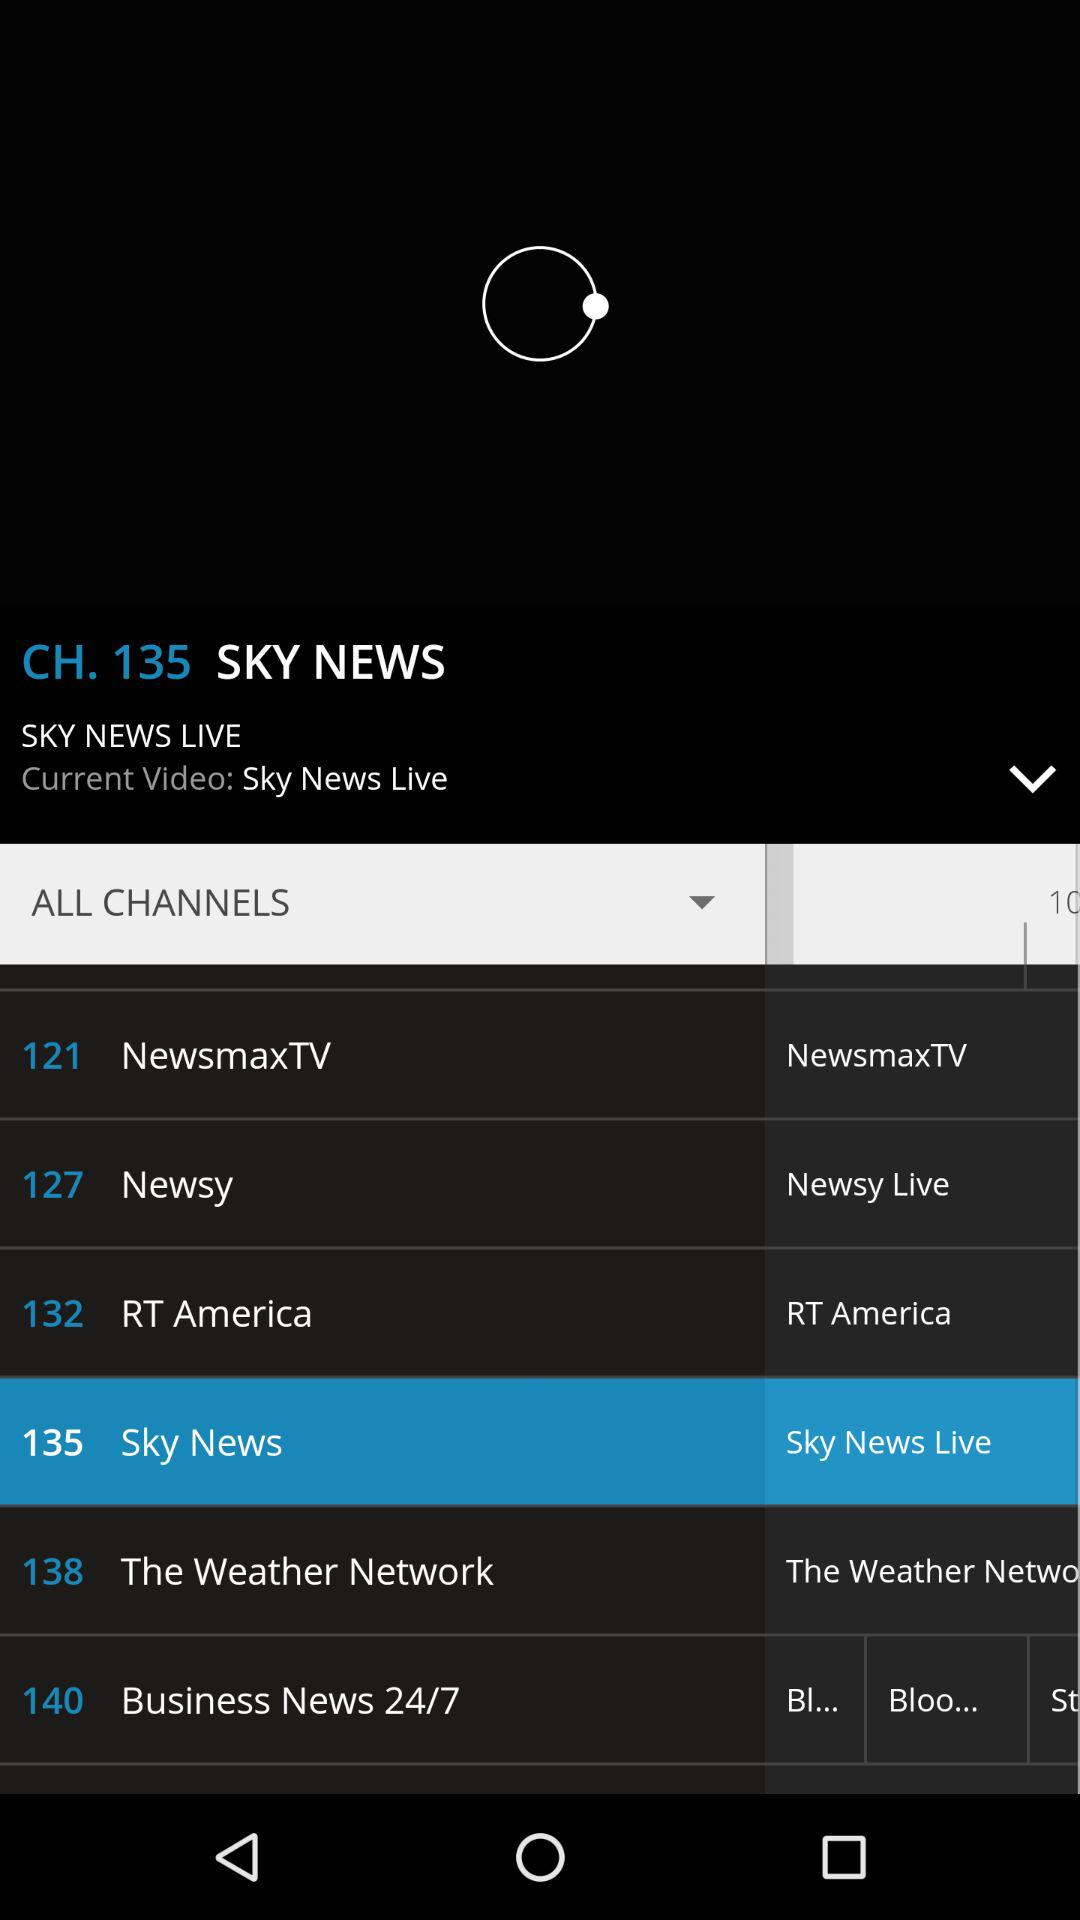What is the channel number of "SKY NEWS"? The channel number is 135. 